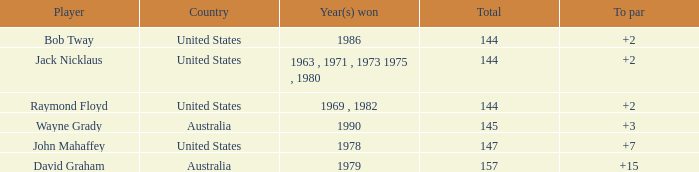What was the mean round score of the player who triumphed in 1978? 147.0. Would you be able to parse every entry in this table? {'header': ['Player', 'Country', 'Year(s) won', 'Total', 'To par'], 'rows': [['Bob Tway', 'United States', '1986', '144', '+2'], ['Jack Nicklaus', 'United States', '1963 , 1971 , 1973 1975 , 1980', '144', '+2'], ['Raymond Floyd', 'United States', '1969 , 1982', '144', '+2'], ['Wayne Grady', 'Australia', '1990', '145', '+3'], ['John Mahaffey', 'United States', '1978', '147', '+7'], ['David Graham', 'Australia', '1979', '157', '+15']]} 